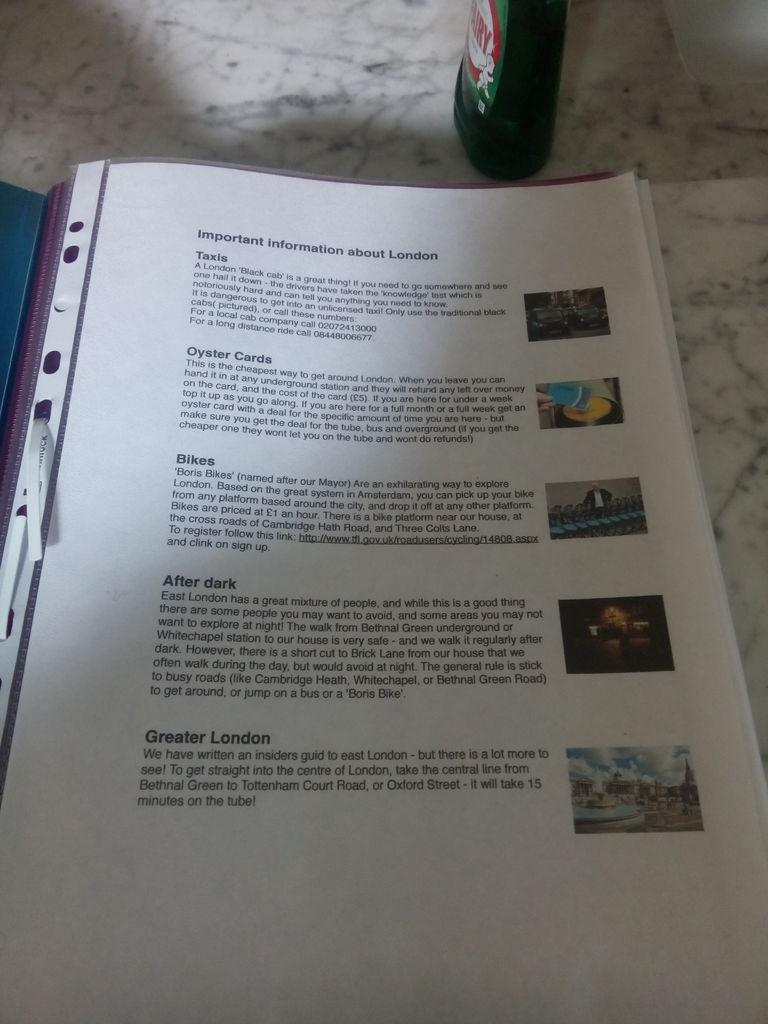Provide a one-sentence caption for the provided image. An informational book on London rests on a counter top. 